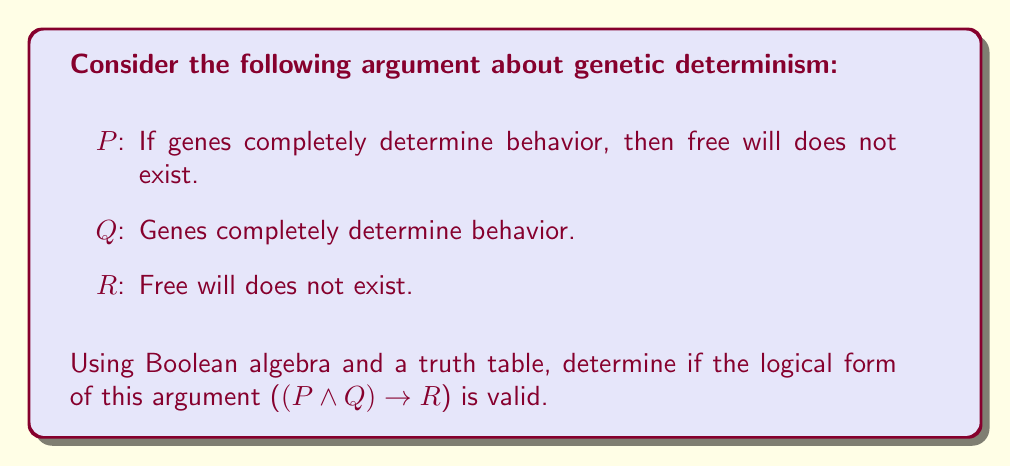What is the answer to this math problem? To determine the validity of this argument using Boolean algebra, we need to construct a truth table for the logical form $(P \land Q) \rightarrow R$. 

Step 1: Identify the variables
P: If genes completely determine behavior, then free will does not exist.
Q: Genes completely determine behavior.
R: Free will does not exist.

Step 2: Construct the truth table

$$
\begin{array}{|c|c|c|c|c|c|}
\hline
P & Q & R & P \land Q & (P \land Q) \rightarrow R \\
\hline
T & T & T & T & T \\
T & T & F & T & F \\
T & F & T & F & T \\
T & F & F & F & T \\
F & T & T & F & T \\
F & T & F & F & T \\
F & F & T & F & T \\
F & F & F & F & T \\
\hline
\end{array}
$$

Step 3: Analyze the truth table
An argument is valid if and only if there is no row in the truth table where all the premises are true (T) and the conclusion is false (F). In this case, we need to look at the $(P \land Q) \rightarrow R$ column.

We can see that there is one row where $(P \land Q)$ is true and $R$ is false, resulting in a false (F) value for the entire expression. This occurs in the second row of the truth table.

Step 4: Interpret the results
The presence of a row where the premises are true and the conclusion is false indicates that this argument form is not logically valid. This means that even if the premises are true, the conclusion does not necessarily follow.

From a philosophical perspective, this result suggests that the logical structure of this argument about genetic determinism is flawed. Even if we accept that genes completely determine behavior and that this would negate free will, we cannot logically conclude that free will does not exist based solely on these premises. This highlights the complexity of the debate surrounding genetic determinism and free will, emphasizing the need for more nuanced arguments in philosophy.
Answer: Invalid 